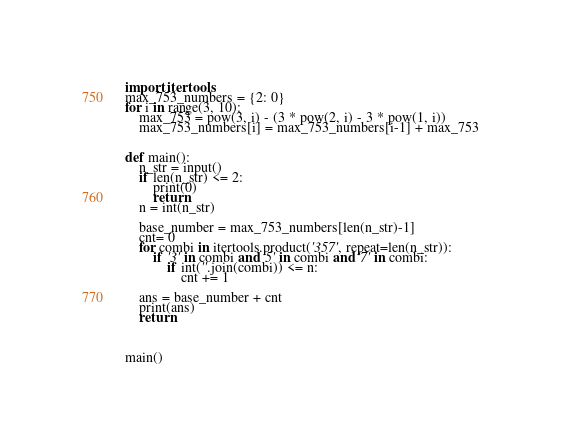Convert code to text. <code><loc_0><loc_0><loc_500><loc_500><_Python_>import itertools
max_753_numbers = {2: 0}
for i in range(3, 10):
    max_753 = pow(3, i) - (3 * pow(2, i) - 3 * pow(1, i))
    max_753_numbers[i] = max_753_numbers[i-1] + max_753


def main():
    n_str = input()
    if len(n_str) <= 2:
        print(0)
        return
    n = int(n_str)

    base_number = max_753_numbers[len(n_str)-1]
    cnt= 0
    for combi in itertools.product('357', repeat=len(n_str)):
        if '3' in combi and '5' in combi and '7' in combi:
            if int(''.join(combi)) <= n:
                cnt += 1

    ans = base_number + cnt
    print(ans)
    return



main()
</code> 